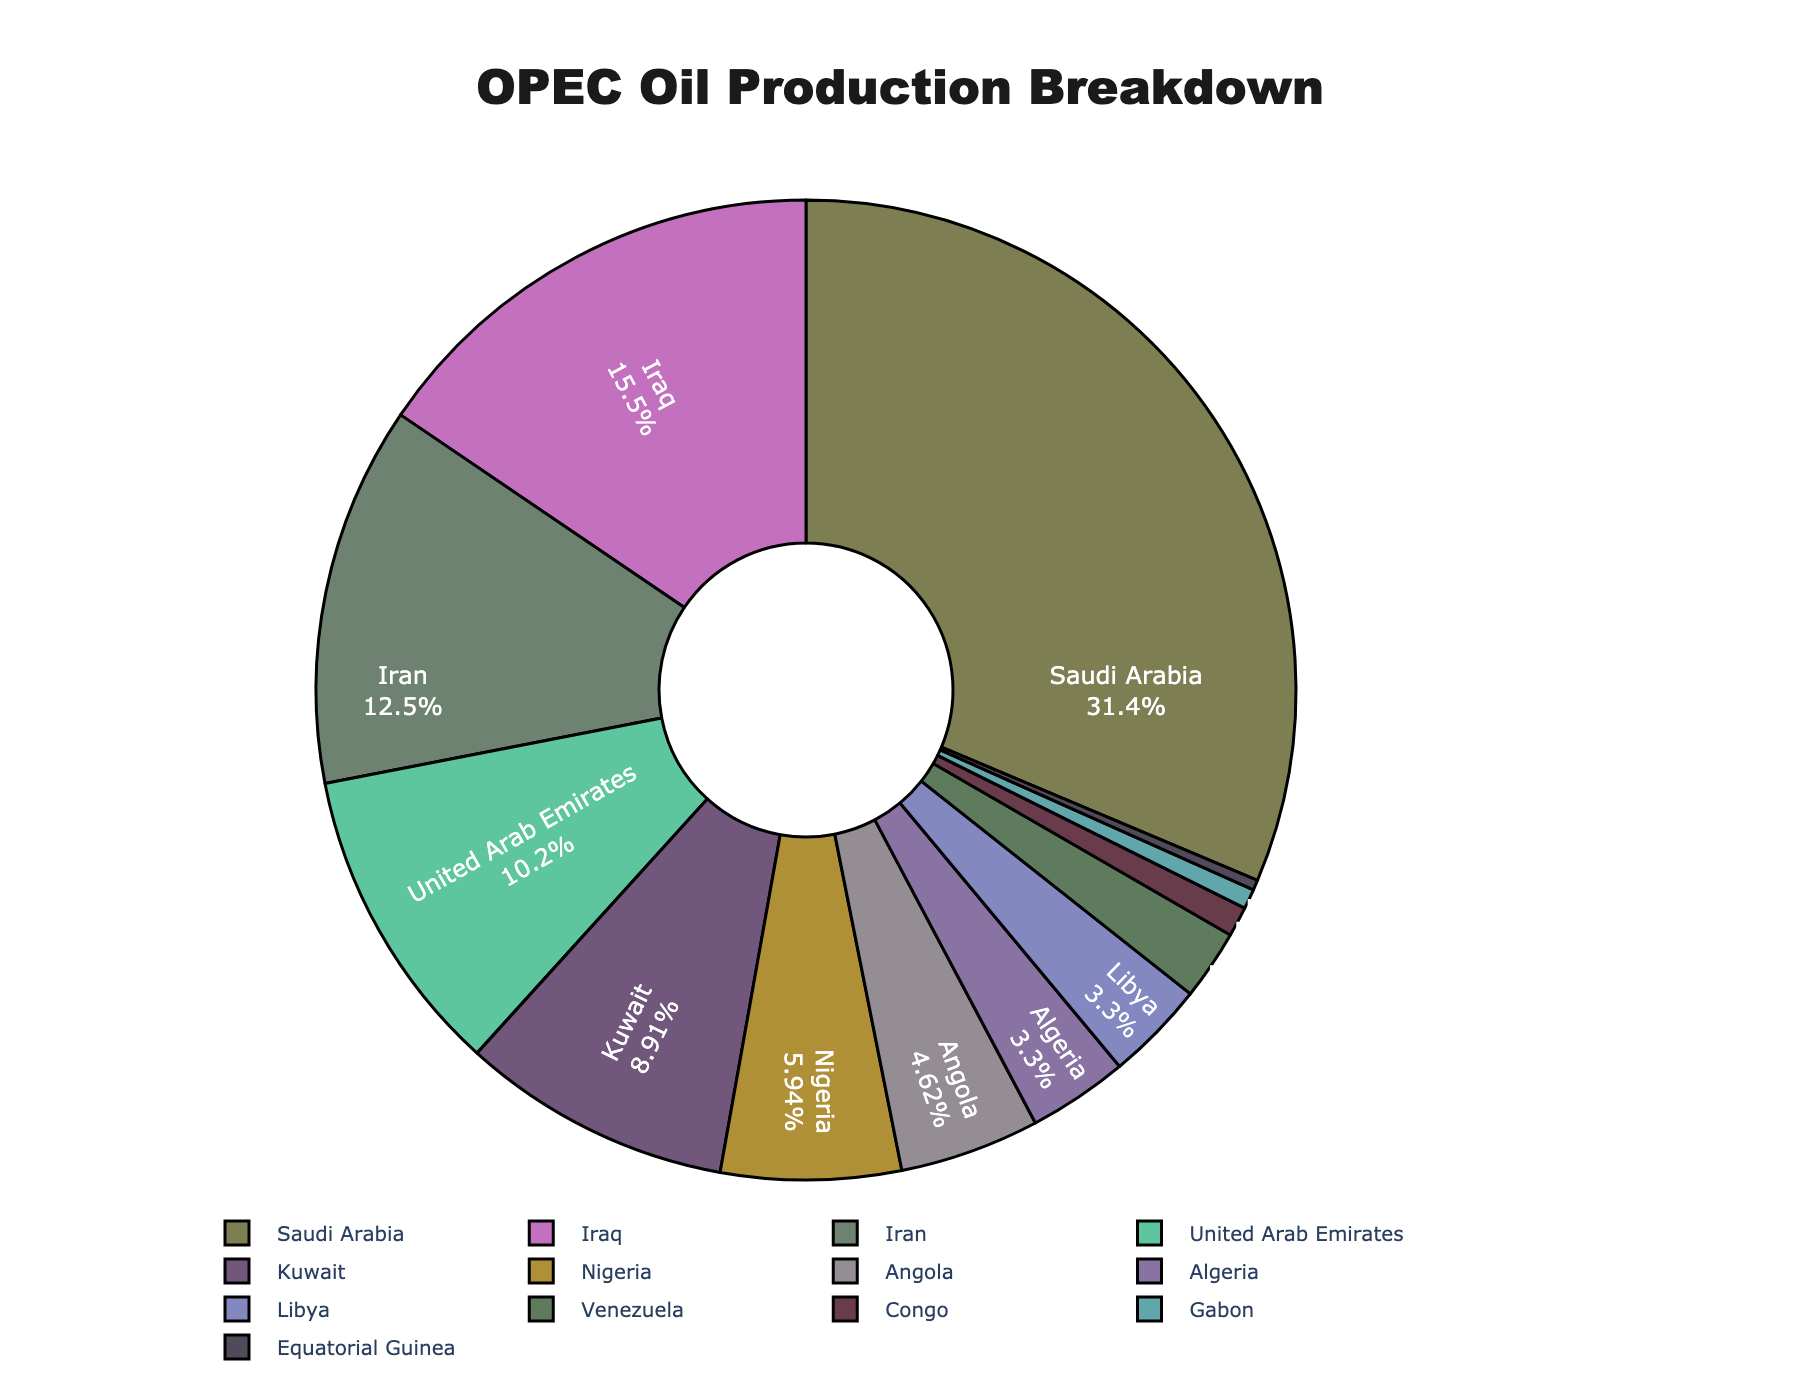Which OPEC member contributes the most to oil production? The slice with the largest percentage label should correspond to the country with the highest oil production. In this case, Saudi Arabia dominates the chart with the largest slice.
Answer: Saudi Arabia Which two countries have the closest oil production values among the identified members? By closely examining the chart, the slices for Algeria and Libya appear to be nearly identical in size, depicting their similar oil production values.
Answer: Algeria and Libya What percentage of total OPEC oil production is contributed by Saudi Arabia and Iraq combined? Add the individual percentages of Saudi Arabia and Iraq from the pie chart. Saudi Arabia’s percentage is the largest, and Iraq’s is the second largest. Assuming 32% for Saudi Arabia and 15.8% for Iraq, we sum these values: 32% + 15.8% = 47.8%.
Answer: 47.8% Is Nigeria’s oil production higher than that of Angola? By comparing their respective slices, Nigeria’s slice is evidently larger than Angola’s slice, indicating that Nigeria's oil production is higher.
Answer: Yes What is the total oil production of countries listed outside of the top four producers? Identify and sum the percentages of all countries except Saudi Arabia, Iraq, Iran, and the United Arab Emirates. If their percentages collectively sum up to say 60%, and subtracting the top four producers' total percentages (sum of their slices): 100% - 60% = 40%.
Answer: 40% Which country has the smallest contribution to OPEC oil production? The smallest slice on the pie chart represents Equatorial Guinea.
Answer: Equatorial Guinea How many countries contribute to less than 5% of the total oil production each? Count the slices that are marked to indicate a percentage below 5%. This includes Angola, Algeria, Libya, Venezuela, Congo, Equatorial Guinea, and Gabon.
Answer: 7 countries What is the difference in oil production between Iran and the United Arab Emirates? Subtract the smaller percentage slice (United Arab Emirates) from the larger percentage slice (Iran). Assuming Iran's slice shows 12.9% and UAE's slice shows 10.5%, the difference is 2.4%.
Answer: 2.4% Visualize the oil production data by color: Which countries' slices are colored in red? Looking for the slices presented in the distinct color red on the pie chart. This requires verifying all the colored slices until the red ones are pinpointed. Without seeing the colors directly, it's hard to provide a specific list, but this ensures understanding of the task process.
Answer: (Country names based on visual identification in red) Which four countries have the largest combined oil production values? From the chart, identify the largest four slices visually evident, being Saudi Arabia, Iraq, Iran, and United Arab Emirates.
Answer: Saudi Arabia, Iraq, Iran, United Arab Emirates 